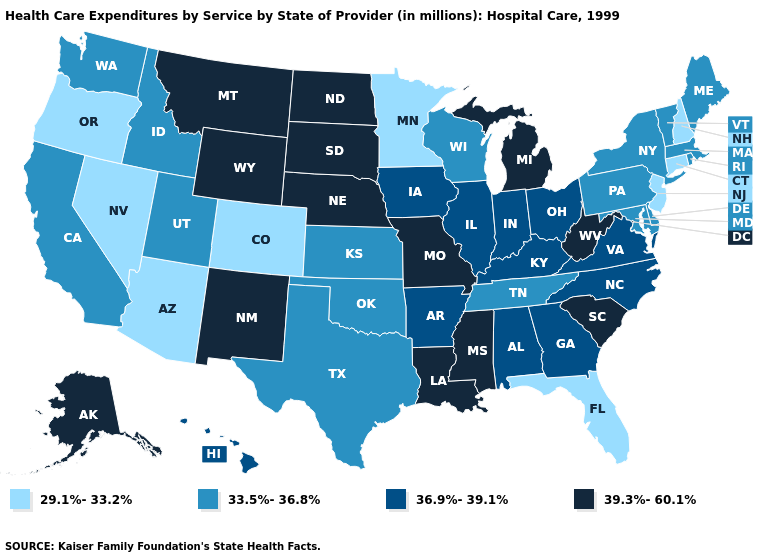What is the lowest value in the Northeast?
Be succinct. 29.1%-33.2%. Does the map have missing data?
Be succinct. No. What is the value of Florida?
Give a very brief answer. 29.1%-33.2%. What is the highest value in the West ?
Give a very brief answer. 39.3%-60.1%. Does Arkansas have the highest value in the South?
Write a very short answer. No. Which states have the lowest value in the West?
Short answer required. Arizona, Colorado, Nevada, Oregon. Name the states that have a value in the range 29.1%-33.2%?
Quick response, please. Arizona, Colorado, Connecticut, Florida, Minnesota, Nevada, New Hampshire, New Jersey, Oregon. What is the value of Wisconsin?
Give a very brief answer. 33.5%-36.8%. Name the states that have a value in the range 33.5%-36.8%?
Write a very short answer. California, Delaware, Idaho, Kansas, Maine, Maryland, Massachusetts, New York, Oklahoma, Pennsylvania, Rhode Island, Tennessee, Texas, Utah, Vermont, Washington, Wisconsin. What is the value of Florida?
Write a very short answer. 29.1%-33.2%. Does Michigan have a higher value than Alabama?
Be succinct. Yes. What is the value of North Carolina?
Give a very brief answer. 36.9%-39.1%. What is the highest value in the USA?
Be succinct. 39.3%-60.1%. What is the value of North Dakota?
Short answer required. 39.3%-60.1%. Name the states that have a value in the range 39.3%-60.1%?
Give a very brief answer. Alaska, Louisiana, Michigan, Mississippi, Missouri, Montana, Nebraska, New Mexico, North Dakota, South Carolina, South Dakota, West Virginia, Wyoming. 